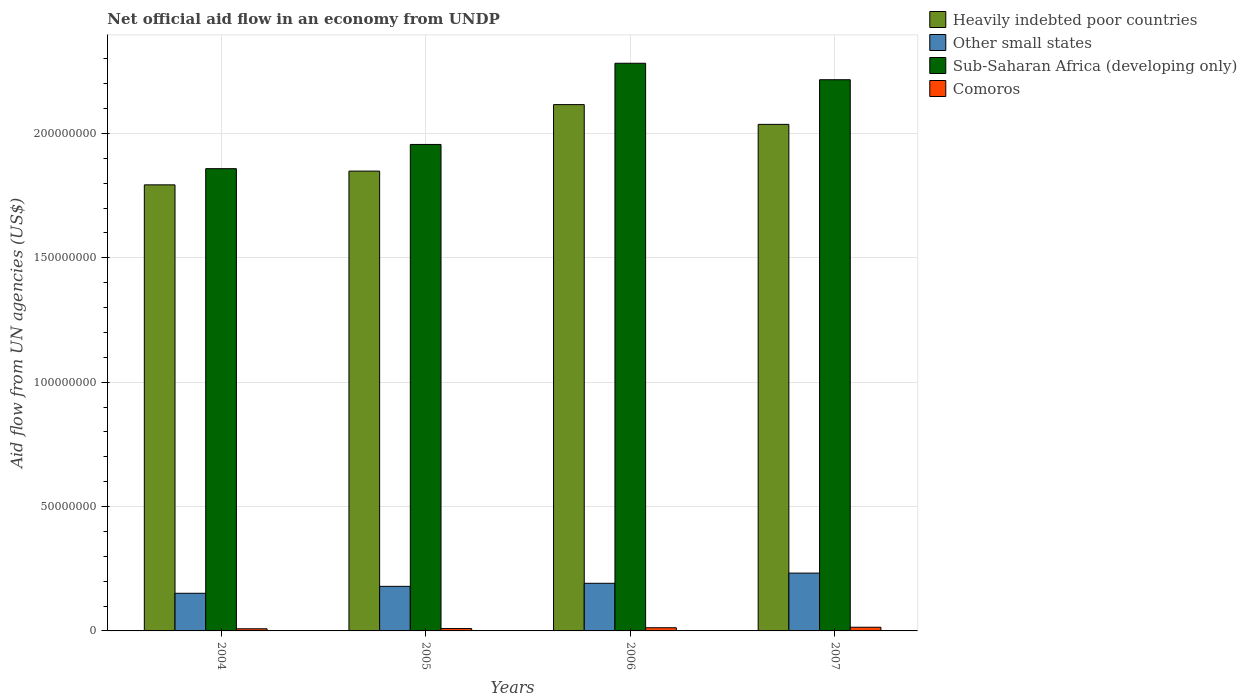Are the number of bars per tick equal to the number of legend labels?
Your answer should be very brief. Yes. How many bars are there on the 2nd tick from the left?
Your response must be concise. 4. How many bars are there on the 1st tick from the right?
Offer a terse response. 4. What is the label of the 3rd group of bars from the left?
Offer a terse response. 2006. What is the net official aid flow in Comoros in 2007?
Your response must be concise. 1.48e+06. Across all years, what is the maximum net official aid flow in Heavily indebted poor countries?
Give a very brief answer. 2.12e+08. Across all years, what is the minimum net official aid flow in Heavily indebted poor countries?
Keep it short and to the point. 1.79e+08. What is the total net official aid flow in Heavily indebted poor countries in the graph?
Your answer should be compact. 7.80e+08. What is the difference between the net official aid flow in Heavily indebted poor countries in 2006 and that in 2007?
Ensure brevity in your answer.  7.94e+06. What is the difference between the net official aid flow in Sub-Saharan Africa (developing only) in 2007 and the net official aid flow in Other small states in 2005?
Provide a succinct answer. 2.04e+08. What is the average net official aid flow in Heavily indebted poor countries per year?
Offer a very short reply. 1.95e+08. In the year 2004, what is the difference between the net official aid flow in Heavily indebted poor countries and net official aid flow in Other small states?
Offer a very short reply. 1.64e+08. In how many years, is the net official aid flow in Comoros greater than 200000000 US$?
Make the answer very short. 0. What is the ratio of the net official aid flow in Other small states in 2004 to that in 2007?
Offer a terse response. 0.65. Is the net official aid flow in Other small states in 2005 less than that in 2007?
Keep it short and to the point. Yes. Is the difference between the net official aid flow in Heavily indebted poor countries in 2005 and 2007 greater than the difference between the net official aid flow in Other small states in 2005 and 2007?
Provide a succinct answer. No. What is the difference between the highest and the second highest net official aid flow in Heavily indebted poor countries?
Provide a short and direct response. 7.94e+06. What is the difference between the highest and the lowest net official aid flow in Comoros?
Provide a succinct answer. 6.20e+05. In how many years, is the net official aid flow in Sub-Saharan Africa (developing only) greater than the average net official aid flow in Sub-Saharan Africa (developing only) taken over all years?
Provide a short and direct response. 2. What does the 4th bar from the left in 2007 represents?
Your response must be concise. Comoros. What does the 4th bar from the right in 2007 represents?
Ensure brevity in your answer.  Heavily indebted poor countries. Is it the case that in every year, the sum of the net official aid flow in Sub-Saharan Africa (developing only) and net official aid flow in Comoros is greater than the net official aid flow in Heavily indebted poor countries?
Your answer should be very brief. Yes. How many bars are there?
Ensure brevity in your answer.  16. How many years are there in the graph?
Ensure brevity in your answer.  4. Does the graph contain grids?
Give a very brief answer. Yes. How are the legend labels stacked?
Provide a succinct answer. Vertical. What is the title of the graph?
Your answer should be very brief. Net official aid flow in an economy from UNDP. What is the label or title of the Y-axis?
Ensure brevity in your answer.  Aid flow from UN agencies (US$). What is the Aid flow from UN agencies (US$) in Heavily indebted poor countries in 2004?
Your answer should be compact. 1.79e+08. What is the Aid flow from UN agencies (US$) of Other small states in 2004?
Your response must be concise. 1.51e+07. What is the Aid flow from UN agencies (US$) in Sub-Saharan Africa (developing only) in 2004?
Provide a succinct answer. 1.86e+08. What is the Aid flow from UN agencies (US$) in Comoros in 2004?
Give a very brief answer. 8.60e+05. What is the Aid flow from UN agencies (US$) of Heavily indebted poor countries in 2005?
Provide a succinct answer. 1.85e+08. What is the Aid flow from UN agencies (US$) in Other small states in 2005?
Keep it short and to the point. 1.79e+07. What is the Aid flow from UN agencies (US$) of Sub-Saharan Africa (developing only) in 2005?
Make the answer very short. 1.96e+08. What is the Aid flow from UN agencies (US$) in Comoros in 2005?
Make the answer very short. 9.50e+05. What is the Aid flow from UN agencies (US$) in Heavily indebted poor countries in 2006?
Provide a succinct answer. 2.12e+08. What is the Aid flow from UN agencies (US$) of Other small states in 2006?
Provide a short and direct response. 1.92e+07. What is the Aid flow from UN agencies (US$) in Sub-Saharan Africa (developing only) in 2006?
Give a very brief answer. 2.28e+08. What is the Aid flow from UN agencies (US$) of Comoros in 2006?
Your answer should be very brief. 1.28e+06. What is the Aid flow from UN agencies (US$) of Heavily indebted poor countries in 2007?
Your answer should be very brief. 2.04e+08. What is the Aid flow from UN agencies (US$) of Other small states in 2007?
Provide a succinct answer. 2.32e+07. What is the Aid flow from UN agencies (US$) in Sub-Saharan Africa (developing only) in 2007?
Offer a terse response. 2.22e+08. What is the Aid flow from UN agencies (US$) of Comoros in 2007?
Offer a very short reply. 1.48e+06. Across all years, what is the maximum Aid flow from UN agencies (US$) in Heavily indebted poor countries?
Provide a succinct answer. 2.12e+08. Across all years, what is the maximum Aid flow from UN agencies (US$) in Other small states?
Your answer should be compact. 2.32e+07. Across all years, what is the maximum Aid flow from UN agencies (US$) of Sub-Saharan Africa (developing only)?
Provide a short and direct response. 2.28e+08. Across all years, what is the maximum Aid flow from UN agencies (US$) in Comoros?
Provide a short and direct response. 1.48e+06. Across all years, what is the minimum Aid flow from UN agencies (US$) in Heavily indebted poor countries?
Provide a short and direct response. 1.79e+08. Across all years, what is the minimum Aid flow from UN agencies (US$) in Other small states?
Provide a succinct answer. 1.51e+07. Across all years, what is the minimum Aid flow from UN agencies (US$) in Sub-Saharan Africa (developing only)?
Your answer should be very brief. 1.86e+08. Across all years, what is the minimum Aid flow from UN agencies (US$) in Comoros?
Provide a succinct answer. 8.60e+05. What is the total Aid flow from UN agencies (US$) of Heavily indebted poor countries in the graph?
Make the answer very short. 7.80e+08. What is the total Aid flow from UN agencies (US$) in Other small states in the graph?
Offer a very short reply. 7.55e+07. What is the total Aid flow from UN agencies (US$) in Sub-Saharan Africa (developing only) in the graph?
Ensure brevity in your answer.  8.31e+08. What is the total Aid flow from UN agencies (US$) of Comoros in the graph?
Ensure brevity in your answer.  4.57e+06. What is the difference between the Aid flow from UN agencies (US$) in Heavily indebted poor countries in 2004 and that in 2005?
Offer a terse response. -5.53e+06. What is the difference between the Aid flow from UN agencies (US$) of Other small states in 2004 and that in 2005?
Offer a very short reply. -2.78e+06. What is the difference between the Aid flow from UN agencies (US$) in Sub-Saharan Africa (developing only) in 2004 and that in 2005?
Your response must be concise. -9.74e+06. What is the difference between the Aid flow from UN agencies (US$) in Comoros in 2004 and that in 2005?
Give a very brief answer. -9.00e+04. What is the difference between the Aid flow from UN agencies (US$) of Heavily indebted poor countries in 2004 and that in 2006?
Your answer should be compact. -3.23e+07. What is the difference between the Aid flow from UN agencies (US$) in Other small states in 2004 and that in 2006?
Your answer should be very brief. -4.01e+06. What is the difference between the Aid flow from UN agencies (US$) in Sub-Saharan Africa (developing only) in 2004 and that in 2006?
Your answer should be compact. -4.24e+07. What is the difference between the Aid flow from UN agencies (US$) of Comoros in 2004 and that in 2006?
Ensure brevity in your answer.  -4.20e+05. What is the difference between the Aid flow from UN agencies (US$) in Heavily indebted poor countries in 2004 and that in 2007?
Offer a terse response. -2.43e+07. What is the difference between the Aid flow from UN agencies (US$) of Other small states in 2004 and that in 2007?
Provide a succinct answer. -8.11e+06. What is the difference between the Aid flow from UN agencies (US$) in Sub-Saharan Africa (developing only) in 2004 and that in 2007?
Your answer should be very brief. -3.58e+07. What is the difference between the Aid flow from UN agencies (US$) of Comoros in 2004 and that in 2007?
Make the answer very short. -6.20e+05. What is the difference between the Aid flow from UN agencies (US$) of Heavily indebted poor countries in 2005 and that in 2006?
Keep it short and to the point. -2.67e+07. What is the difference between the Aid flow from UN agencies (US$) in Other small states in 2005 and that in 2006?
Provide a succinct answer. -1.23e+06. What is the difference between the Aid flow from UN agencies (US$) in Sub-Saharan Africa (developing only) in 2005 and that in 2006?
Offer a terse response. -3.26e+07. What is the difference between the Aid flow from UN agencies (US$) of Comoros in 2005 and that in 2006?
Offer a very short reply. -3.30e+05. What is the difference between the Aid flow from UN agencies (US$) in Heavily indebted poor countries in 2005 and that in 2007?
Your response must be concise. -1.88e+07. What is the difference between the Aid flow from UN agencies (US$) of Other small states in 2005 and that in 2007?
Offer a terse response. -5.33e+06. What is the difference between the Aid flow from UN agencies (US$) of Sub-Saharan Africa (developing only) in 2005 and that in 2007?
Your response must be concise. -2.60e+07. What is the difference between the Aid flow from UN agencies (US$) in Comoros in 2005 and that in 2007?
Make the answer very short. -5.30e+05. What is the difference between the Aid flow from UN agencies (US$) of Heavily indebted poor countries in 2006 and that in 2007?
Ensure brevity in your answer.  7.94e+06. What is the difference between the Aid flow from UN agencies (US$) in Other small states in 2006 and that in 2007?
Your response must be concise. -4.10e+06. What is the difference between the Aid flow from UN agencies (US$) in Sub-Saharan Africa (developing only) in 2006 and that in 2007?
Your response must be concise. 6.62e+06. What is the difference between the Aid flow from UN agencies (US$) of Heavily indebted poor countries in 2004 and the Aid flow from UN agencies (US$) of Other small states in 2005?
Provide a short and direct response. 1.61e+08. What is the difference between the Aid flow from UN agencies (US$) in Heavily indebted poor countries in 2004 and the Aid flow from UN agencies (US$) in Sub-Saharan Africa (developing only) in 2005?
Your answer should be very brief. -1.62e+07. What is the difference between the Aid flow from UN agencies (US$) of Heavily indebted poor countries in 2004 and the Aid flow from UN agencies (US$) of Comoros in 2005?
Keep it short and to the point. 1.78e+08. What is the difference between the Aid flow from UN agencies (US$) of Other small states in 2004 and the Aid flow from UN agencies (US$) of Sub-Saharan Africa (developing only) in 2005?
Offer a very short reply. -1.80e+08. What is the difference between the Aid flow from UN agencies (US$) in Other small states in 2004 and the Aid flow from UN agencies (US$) in Comoros in 2005?
Offer a very short reply. 1.42e+07. What is the difference between the Aid flow from UN agencies (US$) of Sub-Saharan Africa (developing only) in 2004 and the Aid flow from UN agencies (US$) of Comoros in 2005?
Provide a short and direct response. 1.85e+08. What is the difference between the Aid flow from UN agencies (US$) in Heavily indebted poor countries in 2004 and the Aid flow from UN agencies (US$) in Other small states in 2006?
Ensure brevity in your answer.  1.60e+08. What is the difference between the Aid flow from UN agencies (US$) in Heavily indebted poor countries in 2004 and the Aid flow from UN agencies (US$) in Sub-Saharan Africa (developing only) in 2006?
Offer a very short reply. -4.89e+07. What is the difference between the Aid flow from UN agencies (US$) in Heavily indebted poor countries in 2004 and the Aid flow from UN agencies (US$) in Comoros in 2006?
Provide a succinct answer. 1.78e+08. What is the difference between the Aid flow from UN agencies (US$) in Other small states in 2004 and the Aid flow from UN agencies (US$) in Sub-Saharan Africa (developing only) in 2006?
Offer a very short reply. -2.13e+08. What is the difference between the Aid flow from UN agencies (US$) in Other small states in 2004 and the Aid flow from UN agencies (US$) in Comoros in 2006?
Provide a short and direct response. 1.39e+07. What is the difference between the Aid flow from UN agencies (US$) in Sub-Saharan Africa (developing only) in 2004 and the Aid flow from UN agencies (US$) in Comoros in 2006?
Your answer should be compact. 1.85e+08. What is the difference between the Aid flow from UN agencies (US$) of Heavily indebted poor countries in 2004 and the Aid flow from UN agencies (US$) of Other small states in 2007?
Your answer should be compact. 1.56e+08. What is the difference between the Aid flow from UN agencies (US$) of Heavily indebted poor countries in 2004 and the Aid flow from UN agencies (US$) of Sub-Saharan Africa (developing only) in 2007?
Make the answer very short. -4.23e+07. What is the difference between the Aid flow from UN agencies (US$) of Heavily indebted poor countries in 2004 and the Aid flow from UN agencies (US$) of Comoros in 2007?
Ensure brevity in your answer.  1.78e+08. What is the difference between the Aid flow from UN agencies (US$) in Other small states in 2004 and the Aid flow from UN agencies (US$) in Sub-Saharan Africa (developing only) in 2007?
Offer a terse response. -2.06e+08. What is the difference between the Aid flow from UN agencies (US$) of Other small states in 2004 and the Aid flow from UN agencies (US$) of Comoros in 2007?
Your answer should be very brief. 1.37e+07. What is the difference between the Aid flow from UN agencies (US$) of Sub-Saharan Africa (developing only) in 2004 and the Aid flow from UN agencies (US$) of Comoros in 2007?
Provide a succinct answer. 1.84e+08. What is the difference between the Aid flow from UN agencies (US$) in Heavily indebted poor countries in 2005 and the Aid flow from UN agencies (US$) in Other small states in 2006?
Keep it short and to the point. 1.66e+08. What is the difference between the Aid flow from UN agencies (US$) of Heavily indebted poor countries in 2005 and the Aid flow from UN agencies (US$) of Sub-Saharan Africa (developing only) in 2006?
Your answer should be compact. -4.34e+07. What is the difference between the Aid flow from UN agencies (US$) in Heavily indebted poor countries in 2005 and the Aid flow from UN agencies (US$) in Comoros in 2006?
Offer a terse response. 1.84e+08. What is the difference between the Aid flow from UN agencies (US$) of Other small states in 2005 and the Aid flow from UN agencies (US$) of Sub-Saharan Africa (developing only) in 2006?
Your response must be concise. -2.10e+08. What is the difference between the Aid flow from UN agencies (US$) in Other small states in 2005 and the Aid flow from UN agencies (US$) in Comoros in 2006?
Offer a terse response. 1.66e+07. What is the difference between the Aid flow from UN agencies (US$) of Sub-Saharan Africa (developing only) in 2005 and the Aid flow from UN agencies (US$) of Comoros in 2006?
Offer a very short reply. 1.94e+08. What is the difference between the Aid flow from UN agencies (US$) of Heavily indebted poor countries in 2005 and the Aid flow from UN agencies (US$) of Other small states in 2007?
Offer a terse response. 1.62e+08. What is the difference between the Aid flow from UN agencies (US$) in Heavily indebted poor countries in 2005 and the Aid flow from UN agencies (US$) in Sub-Saharan Africa (developing only) in 2007?
Your response must be concise. -3.67e+07. What is the difference between the Aid flow from UN agencies (US$) of Heavily indebted poor countries in 2005 and the Aid flow from UN agencies (US$) of Comoros in 2007?
Make the answer very short. 1.83e+08. What is the difference between the Aid flow from UN agencies (US$) of Other small states in 2005 and the Aid flow from UN agencies (US$) of Sub-Saharan Africa (developing only) in 2007?
Keep it short and to the point. -2.04e+08. What is the difference between the Aid flow from UN agencies (US$) in Other small states in 2005 and the Aid flow from UN agencies (US$) in Comoros in 2007?
Provide a short and direct response. 1.64e+07. What is the difference between the Aid flow from UN agencies (US$) of Sub-Saharan Africa (developing only) in 2005 and the Aid flow from UN agencies (US$) of Comoros in 2007?
Give a very brief answer. 1.94e+08. What is the difference between the Aid flow from UN agencies (US$) of Heavily indebted poor countries in 2006 and the Aid flow from UN agencies (US$) of Other small states in 2007?
Your response must be concise. 1.88e+08. What is the difference between the Aid flow from UN agencies (US$) of Heavily indebted poor countries in 2006 and the Aid flow from UN agencies (US$) of Sub-Saharan Africa (developing only) in 2007?
Offer a very short reply. -1.00e+07. What is the difference between the Aid flow from UN agencies (US$) of Heavily indebted poor countries in 2006 and the Aid flow from UN agencies (US$) of Comoros in 2007?
Offer a very short reply. 2.10e+08. What is the difference between the Aid flow from UN agencies (US$) of Other small states in 2006 and the Aid flow from UN agencies (US$) of Sub-Saharan Africa (developing only) in 2007?
Make the answer very short. -2.02e+08. What is the difference between the Aid flow from UN agencies (US$) in Other small states in 2006 and the Aid flow from UN agencies (US$) in Comoros in 2007?
Offer a very short reply. 1.77e+07. What is the difference between the Aid flow from UN agencies (US$) in Sub-Saharan Africa (developing only) in 2006 and the Aid flow from UN agencies (US$) in Comoros in 2007?
Offer a very short reply. 2.27e+08. What is the average Aid flow from UN agencies (US$) of Heavily indebted poor countries per year?
Provide a short and direct response. 1.95e+08. What is the average Aid flow from UN agencies (US$) in Other small states per year?
Your response must be concise. 1.89e+07. What is the average Aid flow from UN agencies (US$) of Sub-Saharan Africa (developing only) per year?
Offer a very short reply. 2.08e+08. What is the average Aid flow from UN agencies (US$) in Comoros per year?
Your answer should be very brief. 1.14e+06. In the year 2004, what is the difference between the Aid flow from UN agencies (US$) of Heavily indebted poor countries and Aid flow from UN agencies (US$) of Other small states?
Ensure brevity in your answer.  1.64e+08. In the year 2004, what is the difference between the Aid flow from UN agencies (US$) of Heavily indebted poor countries and Aid flow from UN agencies (US$) of Sub-Saharan Africa (developing only)?
Your answer should be compact. -6.51e+06. In the year 2004, what is the difference between the Aid flow from UN agencies (US$) of Heavily indebted poor countries and Aid flow from UN agencies (US$) of Comoros?
Keep it short and to the point. 1.78e+08. In the year 2004, what is the difference between the Aid flow from UN agencies (US$) of Other small states and Aid flow from UN agencies (US$) of Sub-Saharan Africa (developing only)?
Give a very brief answer. -1.71e+08. In the year 2004, what is the difference between the Aid flow from UN agencies (US$) in Other small states and Aid flow from UN agencies (US$) in Comoros?
Offer a terse response. 1.43e+07. In the year 2004, what is the difference between the Aid flow from UN agencies (US$) of Sub-Saharan Africa (developing only) and Aid flow from UN agencies (US$) of Comoros?
Provide a succinct answer. 1.85e+08. In the year 2005, what is the difference between the Aid flow from UN agencies (US$) in Heavily indebted poor countries and Aid flow from UN agencies (US$) in Other small states?
Provide a short and direct response. 1.67e+08. In the year 2005, what is the difference between the Aid flow from UN agencies (US$) in Heavily indebted poor countries and Aid flow from UN agencies (US$) in Sub-Saharan Africa (developing only)?
Provide a succinct answer. -1.07e+07. In the year 2005, what is the difference between the Aid flow from UN agencies (US$) in Heavily indebted poor countries and Aid flow from UN agencies (US$) in Comoros?
Provide a short and direct response. 1.84e+08. In the year 2005, what is the difference between the Aid flow from UN agencies (US$) of Other small states and Aid flow from UN agencies (US$) of Sub-Saharan Africa (developing only)?
Offer a terse response. -1.78e+08. In the year 2005, what is the difference between the Aid flow from UN agencies (US$) of Other small states and Aid flow from UN agencies (US$) of Comoros?
Give a very brief answer. 1.70e+07. In the year 2005, what is the difference between the Aid flow from UN agencies (US$) of Sub-Saharan Africa (developing only) and Aid flow from UN agencies (US$) of Comoros?
Your response must be concise. 1.95e+08. In the year 2006, what is the difference between the Aid flow from UN agencies (US$) in Heavily indebted poor countries and Aid flow from UN agencies (US$) in Other small states?
Offer a terse response. 1.92e+08. In the year 2006, what is the difference between the Aid flow from UN agencies (US$) of Heavily indebted poor countries and Aid flow from UN agencies (US$) of Sub-Saharan Africa (developing only)?
Provide a short and direct response. -1.66e+07. In the year 2006, what is the difference between the Aid flow from UN agencies (US$) of Heavily indebted poor countries and Aid flow from UN agencies (US$) of Comoros?
Your answer should be very brief. 2.10e+08. In the year 2006, what is the difference between the Aid flow from UN agencies (US$) of Other small states and Aid flow from UN agencies (US$) of Sub-Saharan Africa (developing only)?
Your answer should be very brief. -2.09e+08. In the year 2006, what is the difference between the Aid flow from UN agencies (US$) of Other small states and Aid flow from UN agencies (US$) of Comoros?
Your response must be concise. 1.79e+07. In the year 2006, what is the difference between the Aid flow from UN agencies (US$) in Sub-Saharan Africa (developing only) and Aid flow from UN agencies (US$) in Comoros?
Make the answer very short. 2.27e+08. In the year 2007, what is the difference between the Aid flow from UN agencies (US$) of Heavily indebted poor countries and Aid flow from UN agencies (US$) of Other small states?
Your answer should be very brief. 1.80e+08. In the year 2007, what is the difference between the Aid flow from UN agencies (US$) in Heavily indebted poor countries and Aid flow from UN agencies (US$) in Sub-Saharan Africa (developing only)?
Your answer should be compact. -1.80e+07. In the year 2007, what is the difference between the Aid flow from UN agencies (US$) in Heavily indebted poor countries and Aid flow from UN agencies (US$) in Comoros?
Offer a terse response. 2.02e+08. In the year 2007, what is the difference between the Aid flow from UN agencies (US$) of Other small states and Aid flow from UN agencies (US$) of Sub-Saharan Africa (developing only)?
Your answer should be very brief. -1.98e+08. In the year 2007, what is the difference between the Aid flow from UN agencies (US$) of Other small states and Aid flow from UN agencies (US$) of Comoros?
Ensure brevity in your answer.  2.18e+07. In the year 2007, what is the difference between the Aid flow from UN agencies (US$) in Sub-Saharan Africa (developing only) and Aid flow from UN agencies (US$) in Comoros?
Provide a succinct answer. 2.20e+08. What is the ratio of the Aid flow from UN agencies (US$) in Heavily indebted poor countries in 2004 to that in 2005?
Your answer should be very brief. 0.97. What is the ratio of the Aid flow from UN agencies (US$) of Other small states in 2004 to that in 2005?
Provide a short and direct response. 0.84. What is the ratio of the Aid flow from UN agencies (US$) of Sub-Saharan Africa (developing only) in 2004 to that in 2005?
Your response must be concise. 0.95. What is the ratio of the Aid flow from UN agencies (US$) in Comoros in 2004 to that in 2005?
Your answer should be compact. 0.91. What is the ratio of the Aid flow from UN agencies (US$) of Heavily indebted poor countries in 2004 to that in 2006?
Provide a succinct answer. 0.85. What is the ratio of the Aid flow from UN agencies (US$) of Other small states in 2004 to that in 2006?
Ensure brevity in your answer.  0.79. What is the ratio of the Aid flow from UN agencies (US$) of Sub-Saharan Africa (developing only) in 2004 to that in 2006?
Provide a succinct answer. 0.81. What is the ratio of the Aid flow from UN agencies (US$) of Comoros in 2004 to that in 2006?
Your answer should be compact. 0.67. What is the ratio of the Aid flow from UN agencies (US$) of Heavily indebted poor countries in 2004 to that in 2007?
Make the answer very short. 0.88. What is the ratio of the Aid flow from UN agencies (US$) of Other small states in 2004 to that in 2007?
Keep it short and to the point. 0.65. What is the ratio of the Aid flow from UN agencies (US$) in Sub-Saharan Africa (developing only) in 2004 to that in 2007?
Provide a short and direct response. 0.84. What is the ratio of the Aid flow from UN agencies (US$) of Comoros in 2004 to that in 2007?
Ensure brevity in your answer.  0.58. What is the ratio of the Aid flow from UN agencies (US$) of Heavily indebted poor countries in 2005 to that in 2006?
Your answer should be compact. 0.87. What is the ratio of the Aid flow from UN agencies (US$) of Other small states in 2005 to that in 2006?
Keep it short and to the point. 0.94. What is the ratio of the Aid flow from UN agencies (US$) of Sub-Saharan Africa (developing only) in 2005 to that in 2006?
Offer a terse response. 0.86. What is the ratio of the Aid flow from UN agencies (US$) in Comoros in 2005 to that in 2006?
Give a very brief answer. 0.74. What is the ratio of the Aid flow from UN agencies (US$) of Heavily indebted poor countries in 2005 to that in 2007?
Your answer should be compact. 0.91. What is the ratio of the Aid flow from UN agencies (US$) of Other small states in 2005 to that in 2007?
Give a very brief answer. 0.77. What is the ratio of the Aid flow from UN agencies (US$) in Sub-Saharan Africa (developing only) in 2005 to that in 2007?
Provide a short and direct response. 0.88. What is the ratio of the Aid flow from UN agencies (US$) of Comoros in 2005 to that in 2007?
Provide a succinct answer. 0.64. What is the ratio of the Aid flow from UN agencies (US$) in Heavily indebted poor countries in 2006 to that in 2007?
Keep it short and to the point. 1.04. What is the ratio of the Aid flow from UN agencies (US$) of Other small states in 2006 to that in 2007?
Make the answer very short. 0.82. What is the ratio of the Aid flow from UN agencies (US$) in Sub-Saharan Africa (developing only) in 2006 to that in 2007?
Your response must be concise. 1.03. What is the ratio of the Aid flow from UN agencies (US$) in Comoros in 2006 to that in 2007?
Offer a very short reply. 0.86. What is the difference between the highest and the second highest Aid flow from UN agencies (US$) in Heavily indebted poor countries?
Keep it short and to the point. 7.94e+06. What is the difference between the highest and the second highest Aid flow from UN agencies (US$) of Other small states?
Give a very brief answer. 4.10e+06. What is the difference between the highest and the second highest Aid flow from UN agencies (US$) in Sub-Saharan Africa (developing only)?
Offer a terse response. 6.62e+06. What is the difference between the highest and the second highest Aid flow from UN agencies (US$) of Comoros?
Make the answer very short. 2.00e+05. What is the difference between the highest and the lowest Aid flow from UN agencies (US$) of Heavily indebted poor countries?
Keep it short and to the point. 3.23e+07. What is the difference between the highest and the lowest Aid flow from UN agencies (US$) of Other small states?
Provide a succinct answer. 8.11e+06. What is the difference between the highest and the lowest Aid flow from UN agencies (US$) in Sub-Saharan Africa (developing only)?
Offer a very short reply. 4.24e+07. What is the difference between the highest and the lowest Aid flow from UN agencies (US$) in Comoros?
Offer a very short reply. 6.20e+05. 